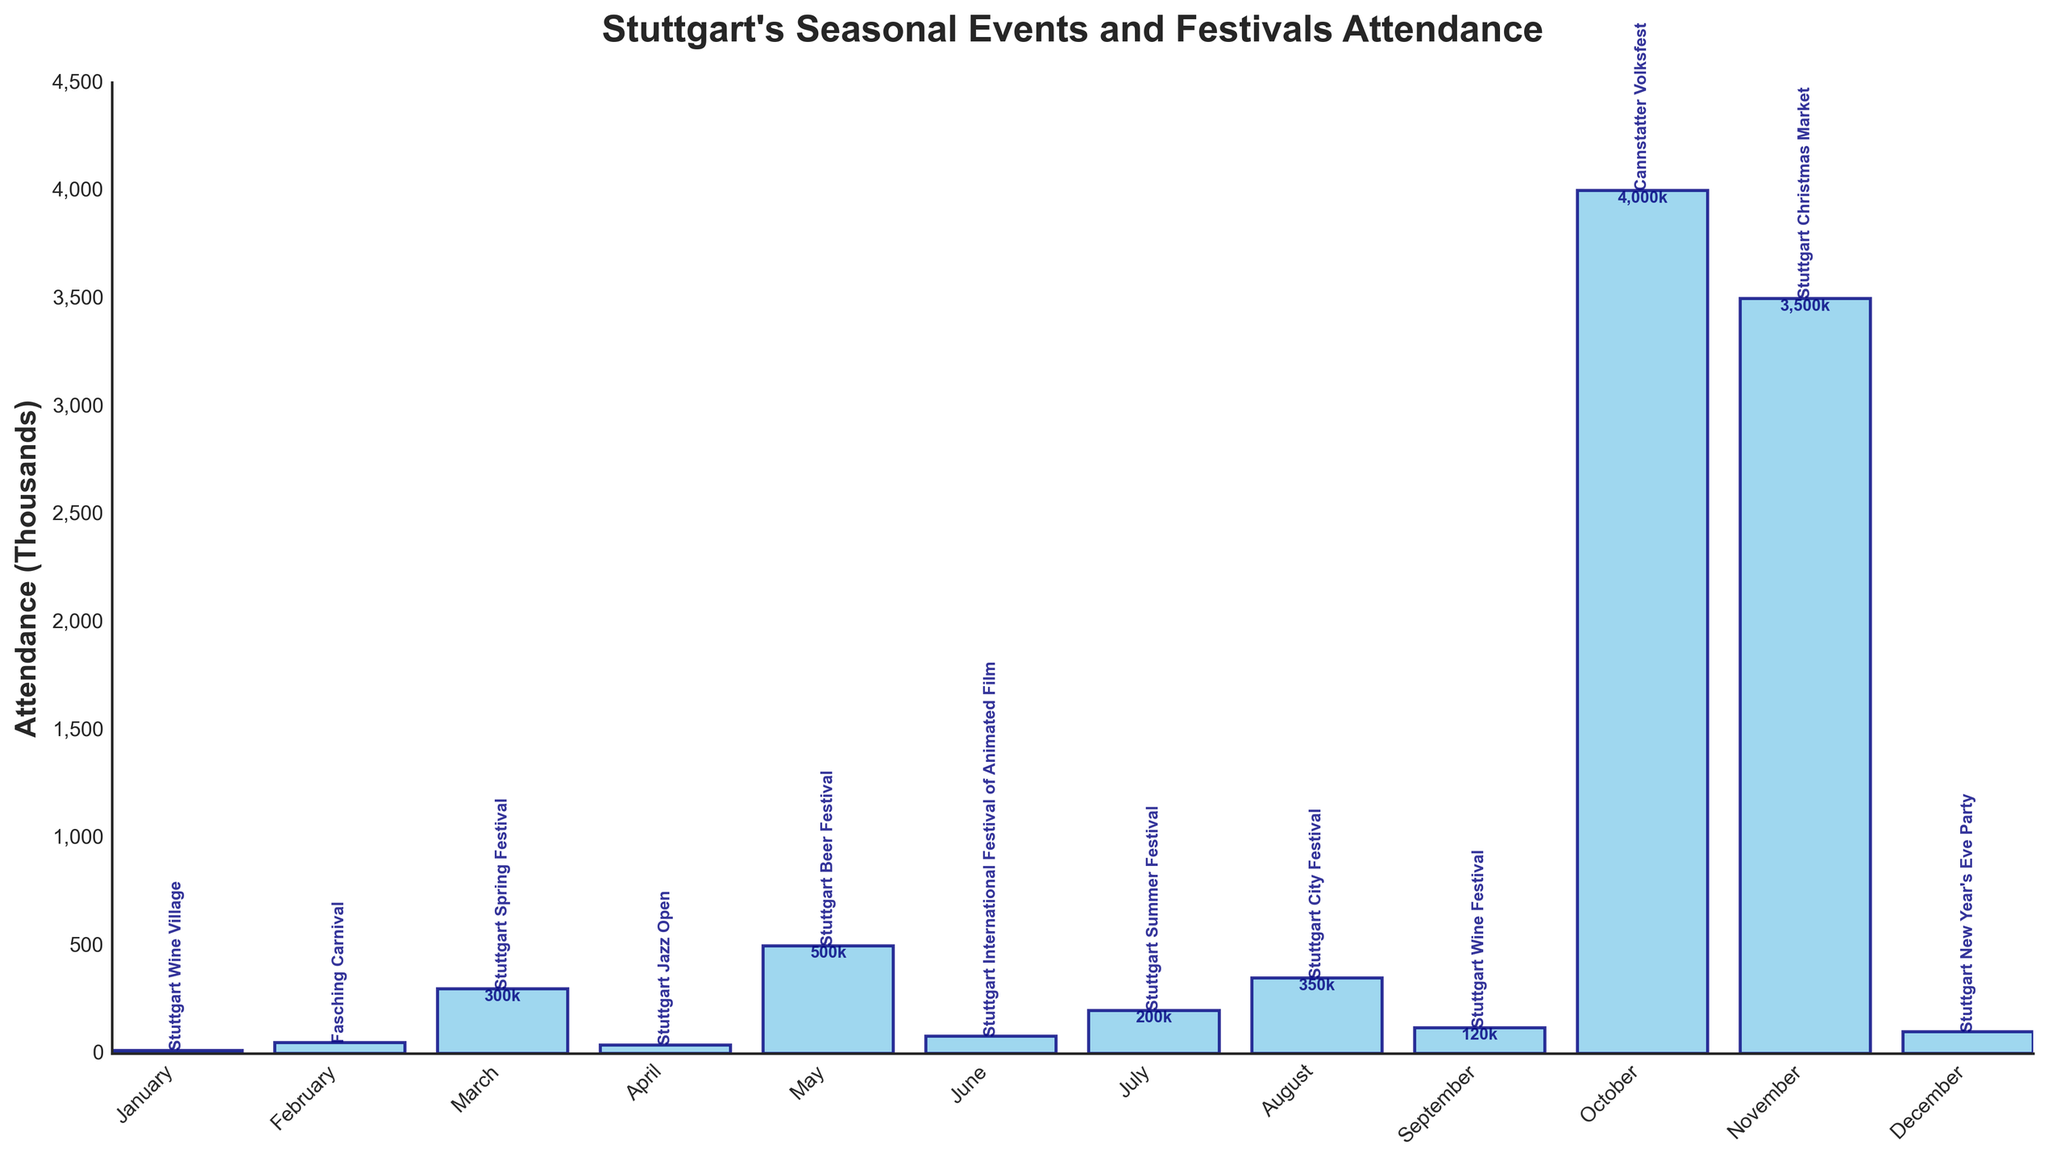What are the three events with the highest attendance? The events with the highest attendance are the ones with the tallest bars. The top three in descending order of height are Cannstatter Volksfest, Stuttgart Christmas Market, and Stuttgart Beer Festival.
Answer: Cannstatter Volksfest, Stuttgart Christmas Market, Stuttgart Beer Festival Which event in April has its name displayed above its bar? The event names are displayed at the top of the bars representing each month. For April, the name displayed above the bar is Stuttgart Jazz Open.
Answer: Stuttgart Jazz Open What is the difference in attendance between the Stuttgart Summer Festival and the Stuttgart Spring Festival? The heights of the bars for July and March correspond to the attendances of the Stuttgart Summer Festival and Stuttgart Spring Festival, respectively. The difference is calculated as 200,000 - 300,000 = -100,000.
Answer: -100,000 How many events have an attendance of more than 1,000,000? The bars representing attendance greater than 1,000,000 should be the tallest, indicating more than 1,000,000. The Cannstatter Volksfest in October and the Stuttgart Christmas Market in November surpass this mark.
Answer: 2 What is the total attendance of events from January to June? Sum the attendance values of events from January to June: 15,000 (January) + 50,000 (February) + 300,000 (March) + 40,000 (April) + 500,000 (May) + 80,000 (June) = 985,000.
Answer: 985,000 Which month has the event with the lowest attendance? The shortest bar on the chart indicates the lowest attendance. January (Stuttgart Wine Village) is the month with the lowest attendance at 15,000.
Answer: January Are there more attendees for the Stuttgart Spring Festival or the Stuttgart Wine Festival? Compare the heights of the bars for March and September. The Stuttgart Spring Festival has an attendance of 300,000, whereas the Stuttgart Wine Festival's attendance is 120,000.
Answer: Stuttgart Spring Festival Is the attendance for the Stuttgart International Festival of Animated Film higher than the Stuttgart Jazz Open? Compare the bars for June and April. The Stuttgart International Festival of Animated Film has 80,000 attendees, and the Stuttgart Jazz Open has 40,000 attendees.
Answer: Yes 